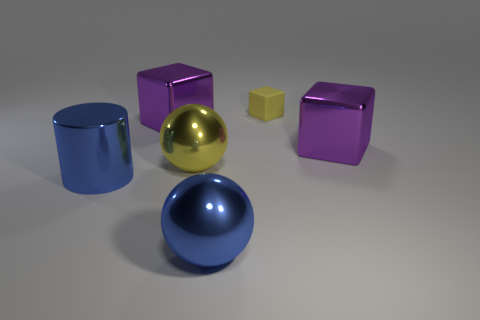Add 1 yellow things. How many objects exist? 7 Subtract all balls. How many objects are left? 4 Add 6 blocks. How many blocks are left? 9 Add 4 yellow metal objects. How many yellow metal objects exist? 5 Subtract 0 gray cylinders. How many objects are left? 6 Subtract all big blue objects. Subtract all large balls. How many objects are left? 2 